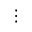Convert formula to latex. <formula><loc_0><loc_0><loc_500><loc_500>\vdots</formula> 